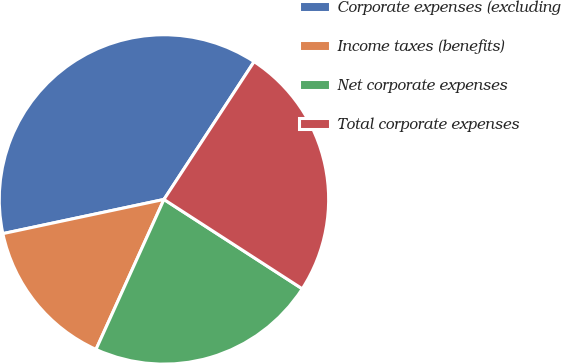<chart> <loc_0><loc_0><loc_500><loc_500><pie_chart><fcel>Corporate expenses (excluding<fcel>Income taxes (benefits)<fcel>Net corporate expenses<fcel>Total corporate expenses<nl><fcel>37.55%<fcel>14.9%<fcel>22.64%<fcel>24.91%<nl></chart> 